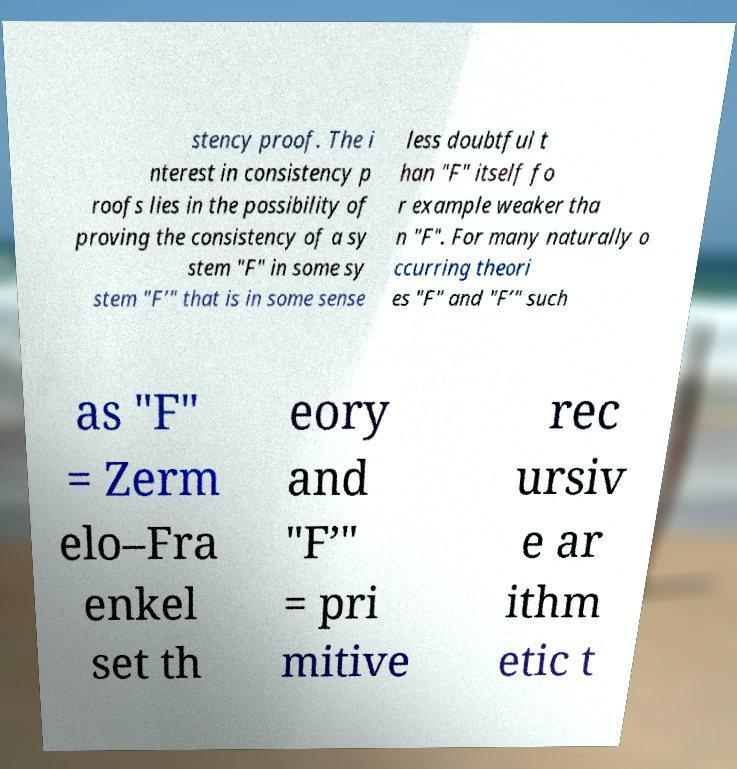What messages or text are displayed in this image? I need them in a readable, typed format. stency proof. The i nterest in consistency p roofs lies in the possibility of proving the consistency of a sy stem "F" in some sy stem "F’" that is in some sense less doubtful t han "F" itself fo r example weaker tha n "F". For many naturally o ccurring theori es "F" and "F’" such as "F" = Zerm elo–Fra enkel set th eory and "F’" = pri mitive rec ursiv e ar ithm etic t 